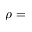<formula> <loc_0><loc_0><loc_500><loc_500>\rho =</formula> 